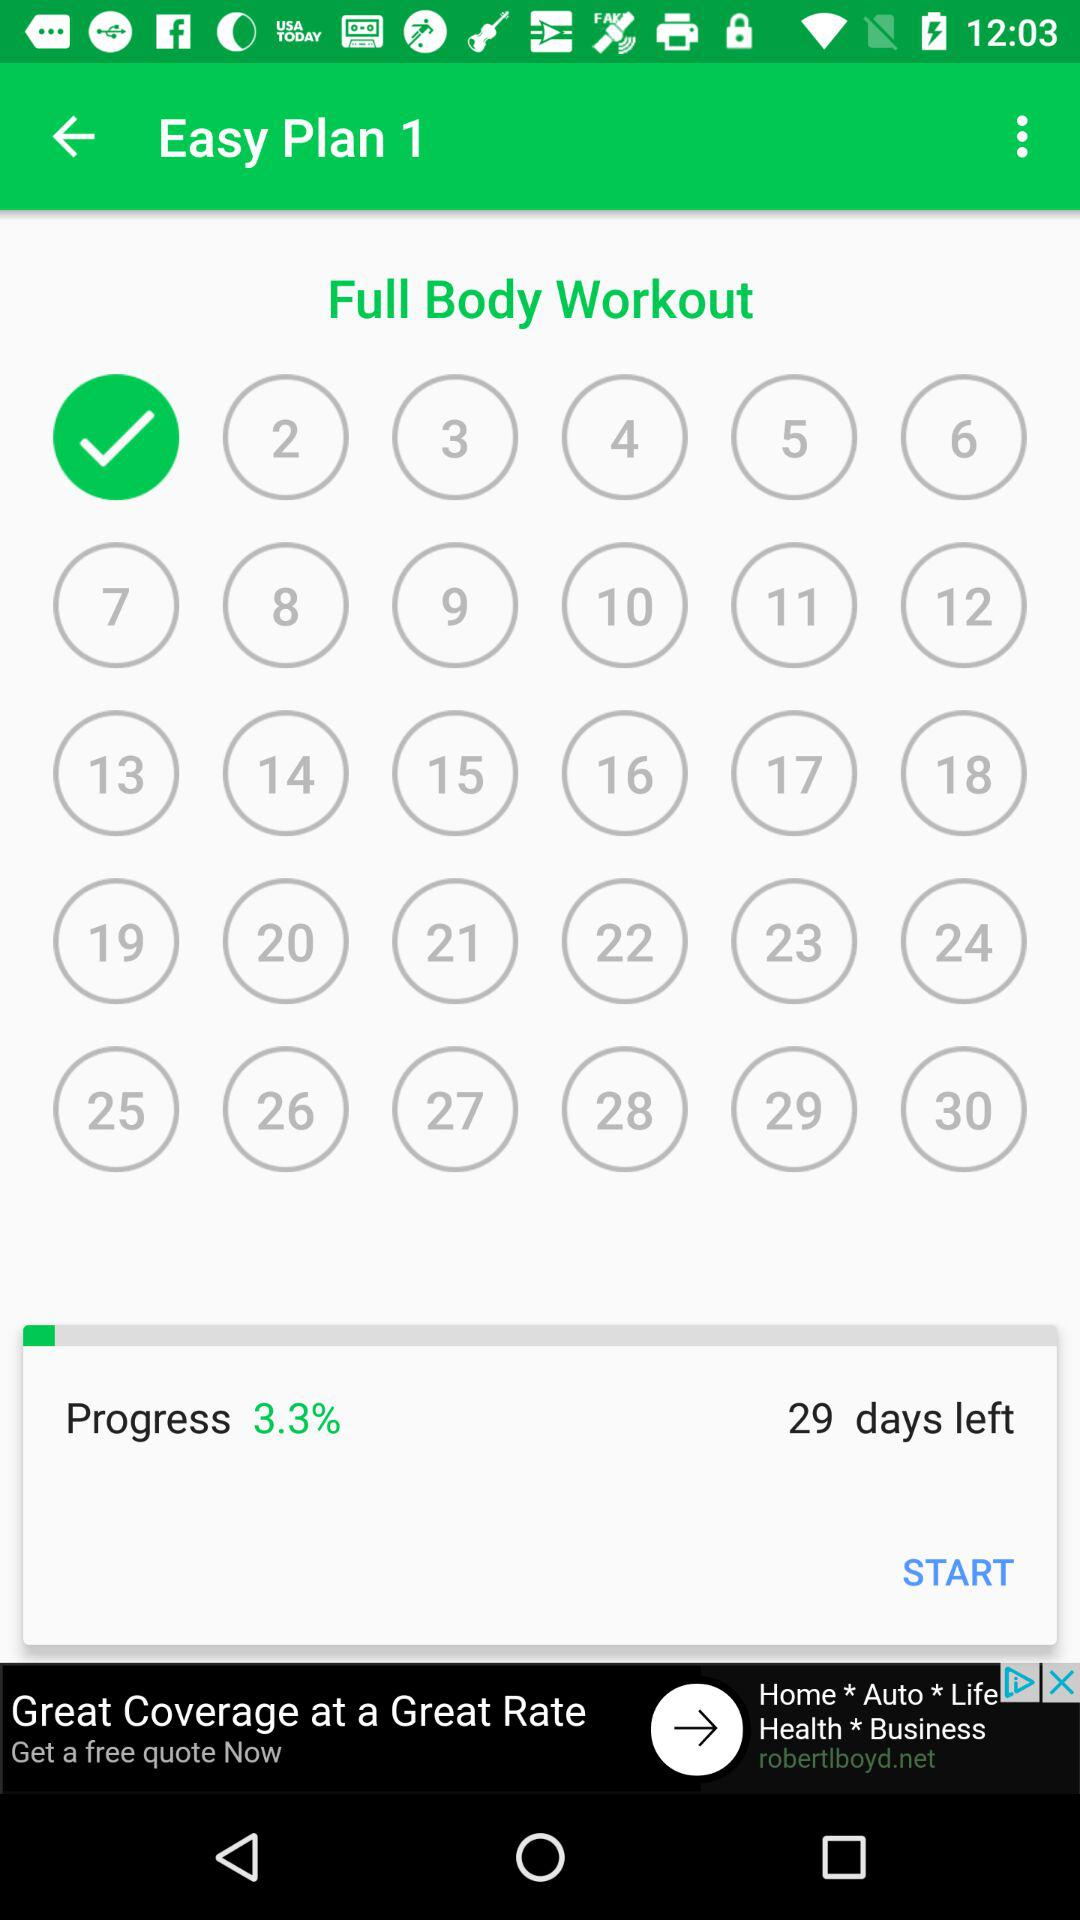How many days are left? The number of days left is 29. 